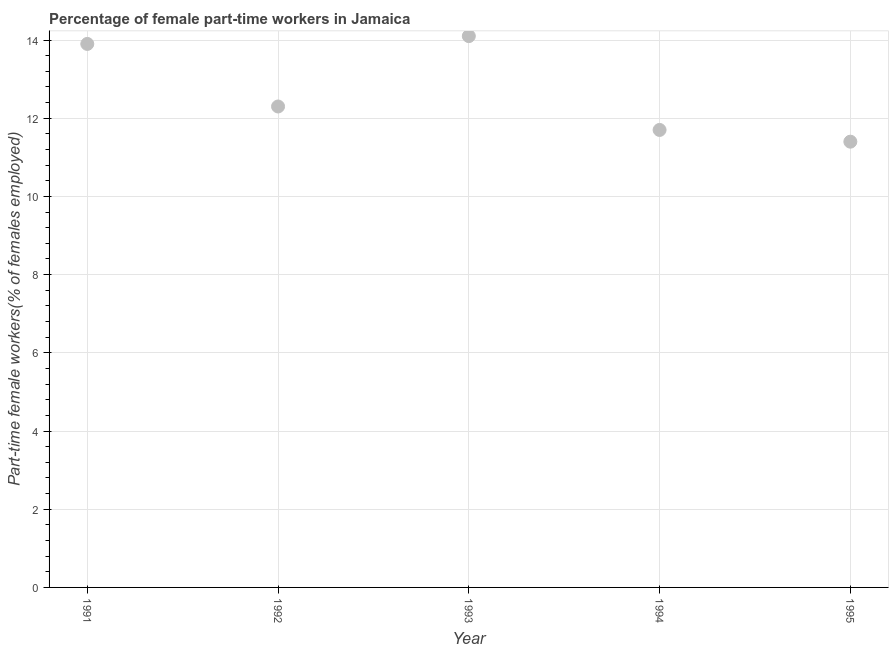What is the percentage of part-time female workers in 1995?
Offer a very short reply. 11.4. Across all years, what is the maximum percentage of part-time female workers?
Offer a very short reply. 14.1. Across all years, what is the minimum percentage of part-time female workers?
Offer a terse response. 11.4. In which year was the percentage of part-time female workers maximum?
Keep it short and to the point. 1993. In which year was the percentage of part-time female workers minimum?
Ensure brevity in your answer.  1995. What is the sum of the percentage of part-time female workers?
Provide a succinct answer. 63.4. What is the difference between the percentage of part-time female workers in 1991 and 1992?
Offer a very short reply. 1.6. What is the average percentage of part-time female workers per year?
Keep it short and to the point. 12.68. What is the median percentage of part-time female workers?
Your answer should be compact. 12.3. In how many years, is the percentage of part-time female workers greater than 12.8 %?
Provide a short and direct response. 2. What is the ratio of the percentage of part-time female workers in 1992 to that in 1994?
Provide a short and direct response. 1.05. Is the difference between the percentage of part-time female workers in 1992 and 1995 greater than the difference between any two years?
Offer a very short reply. No. What is the difference between the highest and the second highest percentage of part-time female workers?
Provide a short and direct response. 0.2. What is the difference between the highest and the lowest percentage of part-time female workers?
Your response must be concise. 2.7. How many years are there in the graph?
Ensure brevity in your answer.  5. What is the difference between two consecutive major ticks on the Y-axis?
Give a very brief answer. 2. Are the values on the major ticks of Y-axis written in scientific E-notation?
Offer a terse response. No. Does the graph contain any zero values?
Your response must be concise. No. Does the graph contain grids?
Provide a succinct answer. Yes. What is the title of the graph?
Make the answer very short. Percentage of female part-time workers in Jamaica. What is the label or title of the X-axis?
Ensure brevity in your answer.  Year. What is the label or title of the Y-axis?
Your answer should be compact. Part-time female workers(% of females employed). What is the Part-time female workers(% of females employed) in 1991?
Offer a terse response. 13.9. What is the Part-time female workers(% of females employed) in 1992?
Offer a very short reply. 12.3. What is the Part-time female workers(% of females employed) in 1993?
Keep it short and to the point. 14.1. What is the Part-time female workers(% of females employed) in 1994?
Your answer should be very brief. 11.7. What is the Part-time female workers(% of females employed) in 1995?
Offer a very short reply. 11.4. What is the difference between the Part-time female workers(% of females employed) in 1991 and 1992?
Your answer should be compact. 1.6. What is the difference between the Part-time female workers(% of females employed) in 1991 and 1995?
Give a very brief answer. 2.5. What is the difference between the Part-time female workers(% of females employed) in 1993 and 1995?
Your answer should be very brief. 2.7. What is the difference between the Part-time female workers(% of females employed) in 1994 and 1995?
Keep it short and to the point. 0.3. What is the ratio of the Part-time female workers(% of females employed) in 1991 to that in 1992?
Your answer should be compact. 1.13. What is the ratio of the Part-time female workers(% of females employed) in 1991 to that in 1993?
Your answer should be very brief. 0.99. What is the ratio of the Part-time female workers(% of females employed) in 1991 to that in 1994?
Your answer should be very brief. 1.19. What is the ratio of the Part-time female workers(% of females employed) in 1991 to that in 1995?
Make the answer very short. 1.22. What is the ratio of the Part-time female workers(% of females employed) in 1992 to that in 1993?
Offer a terse response. 0.87. What is the ratio of the Part-time female workers(% of females employed) in 1992 to that in 1994?
Your response must be concise. 1.05. What is the ratio of the Part-time female workers(% of females employed) in 1992 to that in 1995?
Provide a succinct answer. 1.08. What is the ratio of the Part-time female workers(% of females employed) in 1993 to that in 1994?
Give a very brief answer. 1.21. What is the ratio of the Part-time female workers(% of females employed) in 1993 to that in 1995?
Make the answer very short. 1.24. What is the ratio of the Part-time female workers(% of females employed) in 1994 to that in 1995?
Your answer should be compact. 1.03. 